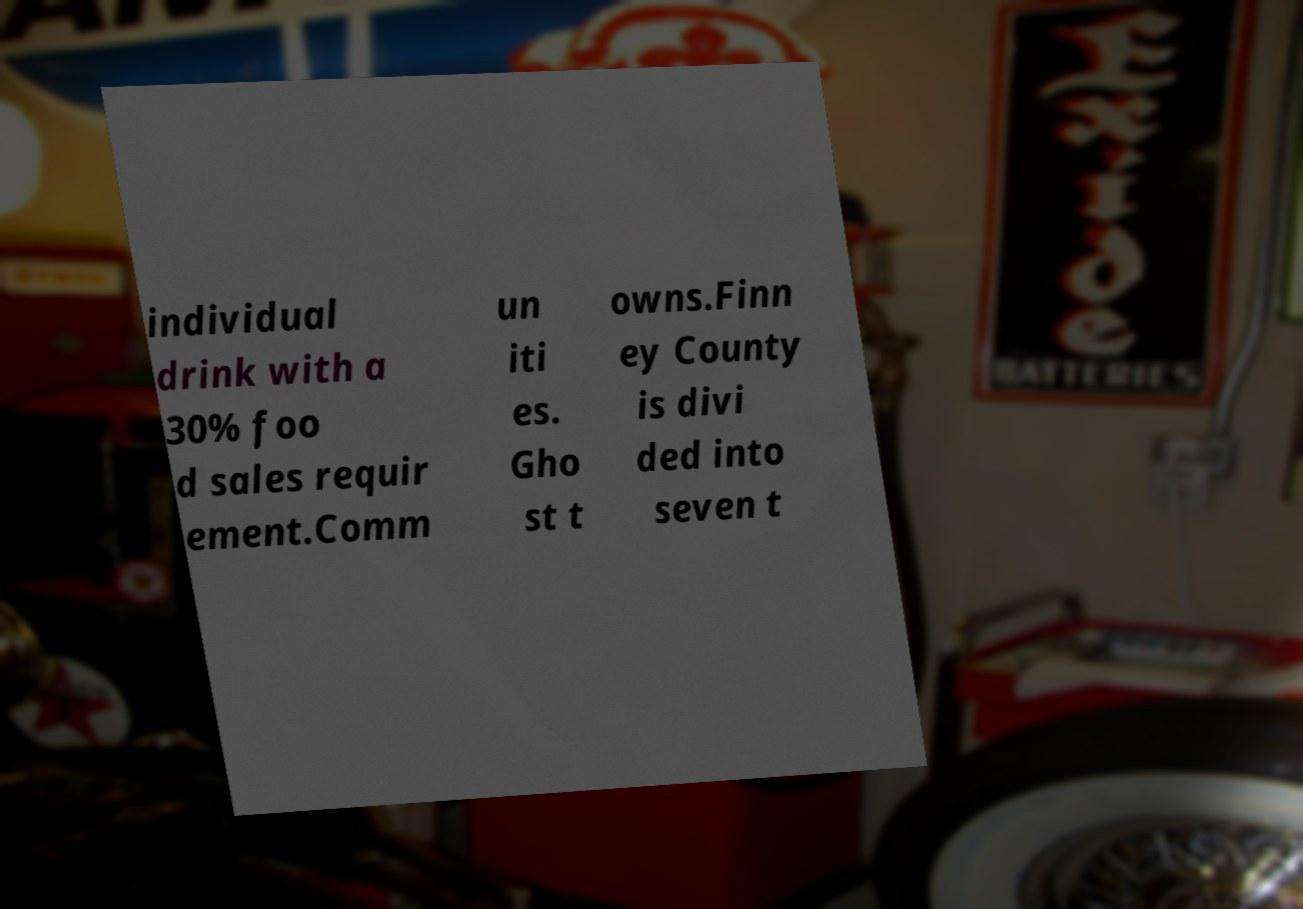Please read and relay the text visible in this image. What does it say? individual drink with a 30% foo d sales requir ement.Comm un iti es. Gho st t owns.Finn ey County is divi ded into seven t 